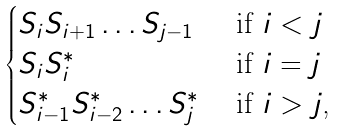<formula> <loc_0><loc_0><loc_500><loc_500>\begin{cases} S _ { i } S _ { i + 1 } \dots S _ { j - 1 } & \text { if $i < j$} \\ S _ { i } S _ { i } ^ { * } & \text { if $i=j$} \\ S _ { i - 1 } ^ { * } S _ { i - 2 } ^ { * } \dots S _ { j } ^ { * } & \text { if $i > j$,} \end{cases}</formula> 